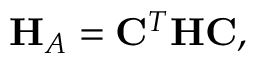Convert formula to latex. <formula><loc_0><loc_0><loc_500><loc_500>H _ { A } = C ^ { T } H C ,</formula> 